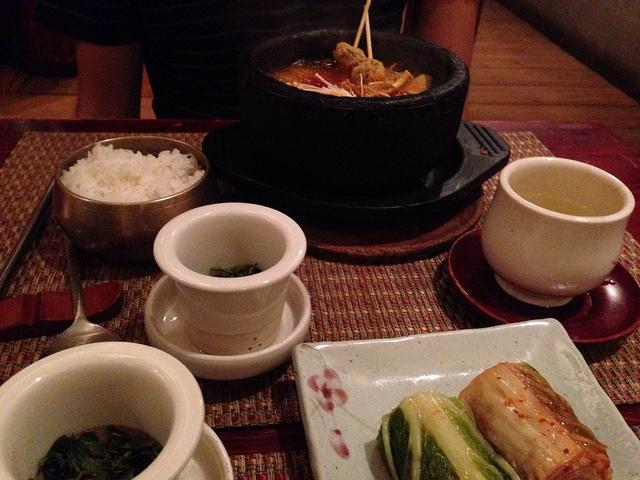What is the black pot used for?

Choices:
A) fondue
B) rice
C) sushi
D) tempura fondue 